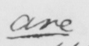Can you read and transcribe this handwriting? are 